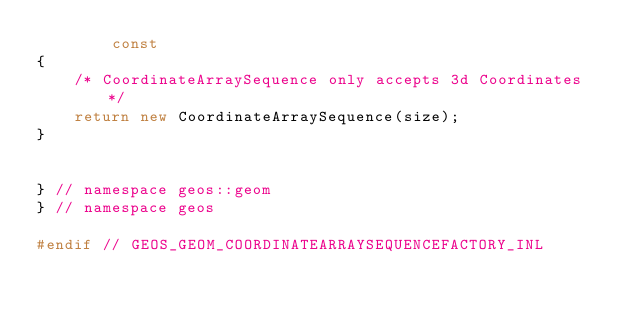<code> <loc_0><loc_0><loc_500><loc_500><_C++_>		const
{
	/* CoordinateArraySequence only accepts 3d Coordinates */
	return new CoordinateArraySequence(size);
}


} // namespace geos::geom
} // namespace geos

#endif // GEOS_GEOM_COORDINATEARRAYSEQUENCEFACTORY_INL

</code> 